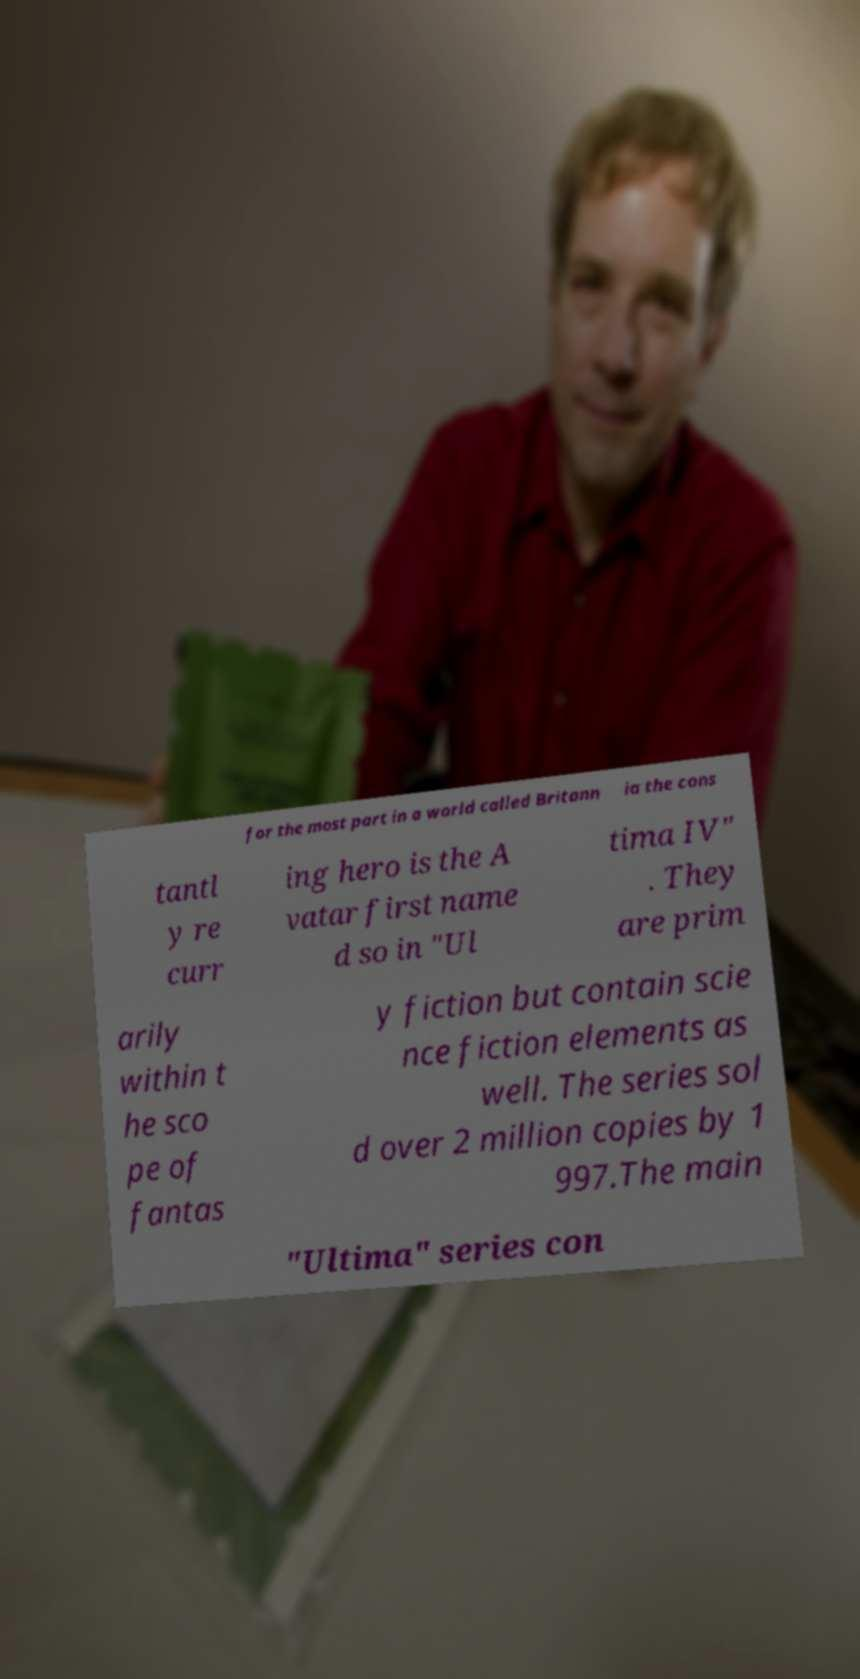For documentation purposes, I need the text within this image transcribed. Could you provide that? for the most part in a world called Britann ia the cons tantl y re curr ing hero is the A vatar first name d so in "Ul tima IV" . They are prim arily within t he sco pe of fantas y fiction but contain scie nce fiction elements as well. The series sol d over 2 million copies by 1 997.The main "Ultima" series con 